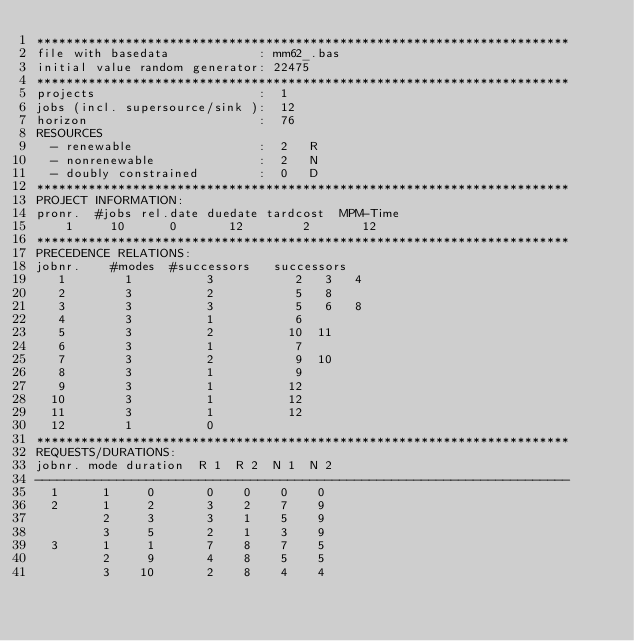<code> <loc_0><loc_0><loc_500><loc_500><_ObjectiveC_>************************************************************************
file with basedata            : mm62_.bas
initial value random generator: 22475
************************************************************************
projects                      :  1
jobs (incl. supersource/sink ):  12
horizon                       :  76
RESOURCES
  - renewable                 :  2   R
  - nonrenewable              :  2   N
  - doubly constrained        :  0   D
************************************************************************
PROJECT INFORMATION:
pronr.  #jobs rel.date duedate tardcost  MPM-Time
    1     10      0       12        2       12
************************************************************************
PRECEDENCE RELATIONS:
jobnr.    #modes  #successors   successors
   1        1          3           2   3   4
   2        3          2           5   8
   3        3          3           5   6   8
   4        3          1           6
   5        3          2          10  11
   6        3          1           7
   7        3          2           9  10
   8        3          1           9
   9        3          1          12
  10        3          1          12
  11        3          1          12
  12        1          0        
************************************************************************
REQUESTS/DURATIONS:
jobnr. mode duration  R 1  R 2  N 1  N 2
------------------------------------------------------------------------
  1      1     0       0    0    0    0
  2      1     2       3    2    7    9
         2     3       3    1    5    9
         3     5       2    1    3    9
  3      1     1       7    8    7    5
         2     9       4    8    5    5
         3    10       2    8    4    4</code> 